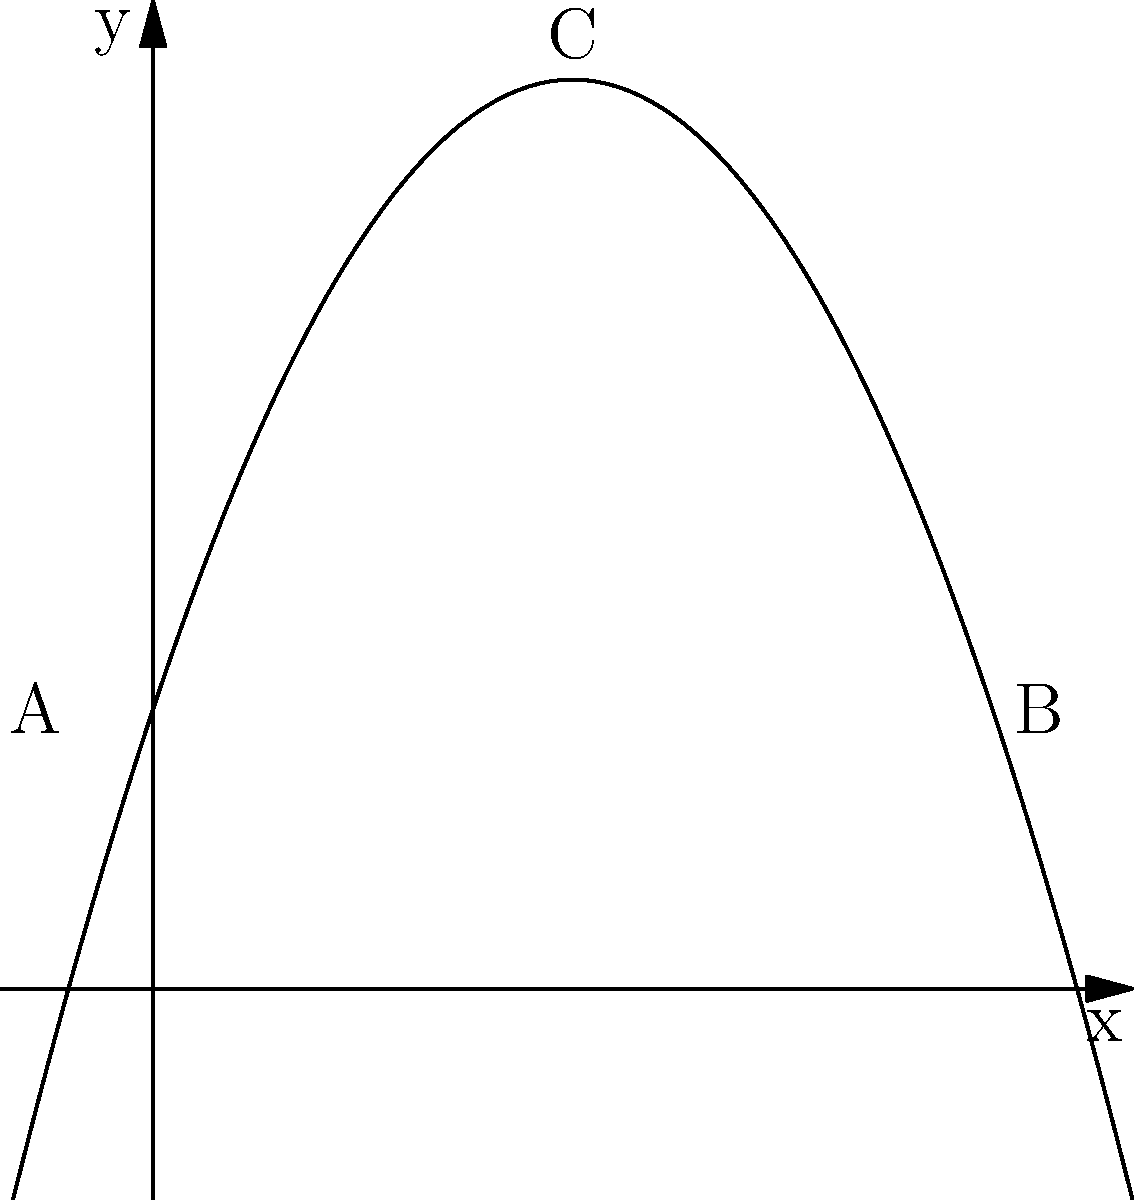A gymnast performing a somersault follows a parabolic path described by the equation $y = -0.5x^2 + 3x + 2$, where $x$ is the horizontal distance traveled and $y$ is the height above the ground (both in meters). If the gymnast takes off at point A and lands at point B, what is the maximum height reached during the somersault? To find the maximum height of the parabolic path, we need to follow these steps:

1) The parabola is given by the equation $y = -0.5x^2 + 3x + 2$

2) The maximum point of a parabola occurs at the vertex. For a parabola in the form $y = ax^2 + bx + c$, the x-coordinate of the vertex is given by $x = -\frac{b}{2a}$

3) In our equation, $a = -0.5$ and $b = 3$. So:

   $x = -\frac{3}{2(-0.5)} = 3$

4) To find the y-coordinate (maximum height), we substitute this x-value back into the original equation:

   $y = -0.5(3)^2 + 3(3) + 2$
   $y = -0.5(9) + 9 + 2$
   $y = -4.5 + 9 + 2$
   $y = 6.5$

5) Therefore, the maximum height reached is 6.5 meters.

This point (3, 6.5) represents the apex of the somersault, which is crucial for gymnasts to understand in order to perfect their technique and ensure safe landings.
Answer: 6.5 meters 